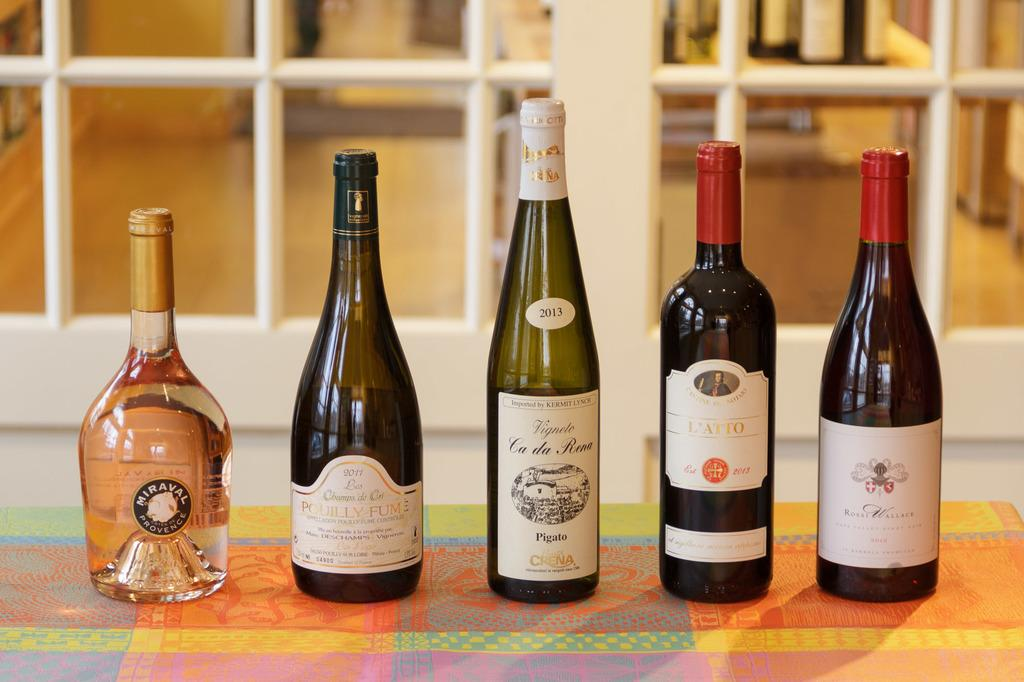<image>
Write a terse but informative summary of the picture. bottles of wine including Vignele Ca Da Rena line a table 